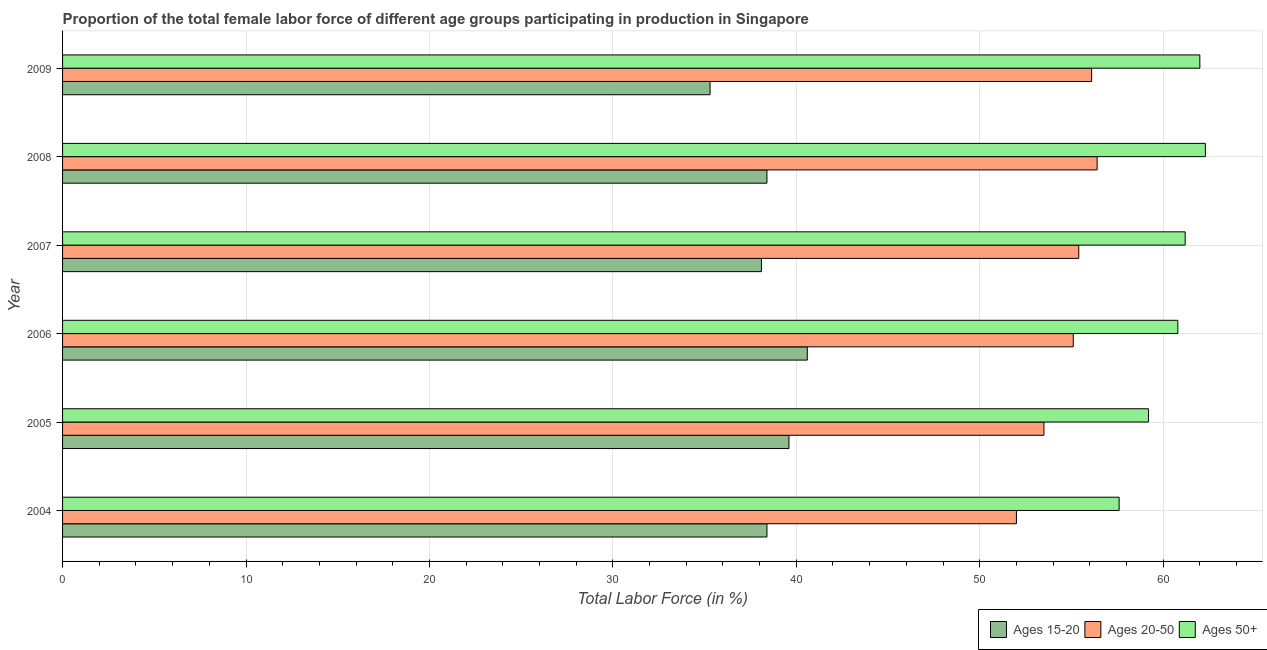How many groups of bars are there?
Offer a terse response. 6. Are the number of bars per tick equal to the number of legend labels?
Make the answer very short. Yes. Are the number of bars on each tick of the Y-axis equal?
Provide a short and direct response. Yes. How many bars are there on the 5th tick from the top?
Provide a succinct answer. 3. How many bars are there on the 2nd tick from the bottom?
Your answer should be very brief. 3. What is the label of the 3rd group of bars from the top?
Offer a very short reply. 2007. In how many cases, is the number of bars for a given year not equal to the number of legend labels?
Provide a succinct answer. 0. What is the percentage of female labor force within the age group 20-50 in 2004?
Your answer should be very brief. 52. Across all years, what is the maximum percentage of female labor force within the age group 20-50?
Ensure brevity in your answer.  56.4. Across all years, what is the minimum percentage of female labor force above age 50?
Provide a succinct answer. 57.6. In which year was the percentage of female labor force within the age group 20-50 maximum?
Your answer should be compact. 2008. What is the total percentage of female labor force within the age group 20-50 in the graph?
Make the answer very short. 328.5. What is the difference between the percentage of female labor force within the age group 20-50 in 2007 and the percentage of female labor force above age 50 in 2005?
Keep it short and to the point. -3.8. What is the average percentage of female labor force within the age group 15-20 per year?
Offer a terse response. 38.4. In the year 2004, what is the difference between the percentage of female labor force within the age group 15-20 and percentage of female labor force above age 50?
Your answer should be compact. -19.2. Is the percentage of female labor force within the age group 15-20 in 2004 less than that in 2005?
Your response must be concise. Yes. What is the difference between the highest and the lowest percentage of female labor force within the age group 20-50?
Give a very brief answer. 4.4. What does the 1st bar from the top in 2008 represents?
Your response must be concise. Ages 50+. What does the 3rd bar from the bottom in 2008 represents?
Offer a terse response. Ages 50+. Is it the case that in every year, the sum of the percentage of female labor force within the age group 15-20 and percentage of female labor force within the age group 20-50 is greater than the percentage of female labor force above age 50?
Your response must be concise. Yes. Are all the bars in the graph horizontal?
Keep it short and to the point. Yes. How many years are there in the graph?
Your answer should be compact. 6. What is the difference between two consecutive major ticks on the X-axis?
Your answer should be compact. 10. How many legend labels are there?
Your answer should be compact. 3. What is the title of the graph?
Make the answer very short. Proportion of the total female labor force of different age groups participating in production in Singapore. What is the label or title of the X-axis?
Ensure brevity in your answer.  Total Labor Force (in %). What is the label or title of the Y-axis?
Your response must be concise. Year. What is the Total Labor Force (in %) of Ages 15-20 in 2004?
Offer a very short reply. 38.4. What is the Total Labor Force (in %) of Ages 20-50 in 2004?
Your response must be concise. 52. What is the Total Labor Force (in %) of Ages 50+ in 2004?
Your response must be concise. 57.6. What is the Total Labor Force (in %) of Ages 15-20 in 2005?
Your answer should be very brief. 39.6. What is the Total Labor Force (in %) in Ages 20-50 in 2005?
Give a very brief answer. 53.5. What is the Total Labor Force (in %) of Ages 50+ in 2005?
Provide a short and direct response. 59.2. What is the Total Labor Force (in %) in Ages 15-20 in 2006?
Make the answer very short. 40.6. What is the Total Labor Force (in %) in Ages 20-50 in 2006?
Give a very brief answer. 55.1. What is the Total Labor Force (in %) of Ages 50+ in 2006?
Provide a succinct answer. 60.8. What is the Total Labor Force (in %) in Ages 15-20 in 2007?
Keep it short and to the point. 38.1. What is the Total Labor Force (in %) of Ages 20-50 in 2007?
Give a very brief answer. 55.4. What is the Total Labor Force (in %) in Ages 50+ in 2007?
Provide a succinct answer. 61.2. What is the Total Labor Force (in %) in Ages 15-20 in 2008?
Provide a succinct answer. 38.4. What is the Total Labor Force (in %) of Ages 20-50 in 2008?
Your response must be concise. 56.4. What is the Total Labor Force (in %) of Ages 50+ in 2008?
Make the answer very short. 62.3. What is the Total Labor Force (in %) of Ages 15-20 in 2009?
Give a very brief answer. 35.3. What is the Total Labor Force (in %) in Ages 20-50 in 2009?
Offer a very short reply. 56.1. What is the Total Labor Force (in %) of Ages 50+ in 2009?
Your answer should be very brief. 62. Across all years, what is the maximum Total Labor Force (in %) of Ages 15-20?
Your answer should be compact. 40.6. Across all years, what is the maximum Total Labor Force (in %) in Ages 20-50?
Your answer should be compact. 56.4. Across all years, what is the maximum Total Labor Force (in %) in Ages 50+?
Provide a succinct answer. 62.3. Across all years, what is the minimum Total Labor Force (in %) of Ages 15-20?
Keep it short and to the point. 35.3. Across all years, what is the minimum Total Labor Force (in %) in Ages 20-50?
Your answer should be very brief. 52. Across all years, what is the minimum Total Labor Force (in %) in Ages 50+?
Give a very brief answer. 57.6. What is the total Total Labor Force (in %) of Ages 15-20 in the graph?
Your answer should be compact. 230.4. What is the total Total Labor Force (in %) of Ages 20-50 in the graph?
Your answer should be very brief. 328.5. What is the total Total Labor Force (in %) of Ages 50+ in the graph?
Your response must be concise. 363.1. What is the difference between the Total Labor Force (in %) of Ages 15-20 in 2004 and that in 2005?
Give a very brief answer. -1.2. What is the difference between the Total Labor Force (in %) in Ages 15-20 in 2004 and that in 2006?
Keep it short and to the point. -2.2. What is the difference between the Total Labor Force (in %) of Ages 50+ in 2004 and that in 2006?
Offer a terse response. -3.2. What is the difference between the Total Labor Force (in %) of Ages 15-20 in 2004 and that in 2007?
Give a very brief answer. 0.3. What is the difference between the Total Labor Force (in %) of Ages 50+ in 2004 and that in 2007?
Provide a succinct answer. -3.6. What is the difference between the Total Labor Force (in %) in Ages 50+ in 2004 and that in 2008?
Your answer should be compact. -4.7. What is the difference between the Total Labor Force (in %) of Ages 20-50 in 2004 and that in 2009?
Make the answer very short. -4.1. What is the difference between the Total Labor Force (in %) in Ages 20-50 in 2005 and that in 2006?
Offer a terse response. -1.6. What is the difference between the Total Labor Force (in %) of Ages 50+ in 2005 and that in 2006?
Offer a terse response. -1.6. What is the difference between the Total Labor Force (in %) of Ages 15-20 in 2005 and that in 2007?
Offer a terse response. 1.5. What is the difference between the Total Labor Force (in %) in Ages 20-50 in 2005 and that in 2007?
Your answer should be very brief. -1.9. What is the difference between the Total Labor Force (in %) of Ages 20-50 in 2005 and that in 2008?
Ensure brevity in your answer.  -2.9. What is the difference between the Total Labor Force (in %) in Ages 15-20 in 2005 and that in 2009?
Make the answer very short. 4.3. What is the difference between the Total Labor Force (in %) of Ages 20-50 in 2006 and that in 2007?
Give a very brief answer. -0.3. What is the difference between the Total Labor Force (in %) of Ages 50+ in 2006 and that in 2007?
Give a very brief answer. -0.4. What is the difference between the Total Labor Force (in %) in Ages 15-20 in 2006 and that in 2008?
Provide a short and direct response. 2.2. What is the difference between the Total Labor Force (in %) in Ages 20-50 in 2006 and that in 2008?
Give a very brief answer. -1.3. What is the difference between the Total Labor Force (in %) in Ages 20-50 in 2006 and that in 2009?
Offer a very short reply. -1. What is the difference between the Total Labor Force (in %) of Ages 50+ in 2006 and that in 2009?
Provide a short and direct response. -1.2. What is the difference between the Total Labor Force (in %) in Ages 15-20 in 2007 and that in 2008?
Keep it short and to the point. -0.3. What is the difference between the Total Labor Force (in %) in Ages 50+ in 2007 and that in 2008?
Keep it short and to the point. -1.1. What is the difference between the Total Labor Force (in %) in Ages 15-20 in 2007 and that in 2009?
Offer a terse response. 2.8. What is the difference between the Total Labor Force (in %) in Ages 20-50 in 2007 and that in 2009?
Your response must be concise. -0.7. What is the difference between the Total Labor Force (in %) of Ages 50+ in 2007 and that in 2009?
Ensure brevity in your answer.  -0.8. What is the difference between the Total Labor Force (in %) of Ages 15-20 in 2008 and that in 2009?
Provide a short and direct response. 3.1. What is the difference between the Total Labor Force (in %) of Ages 20-50 in 2008 and that in 2009?
Offer a very short reply. 0.3. What is the difference between the Total Labor Force (in %) of Ages 15-20 in 2004 and the Total Labor Force (in %) of Ages 20-50 in 2005?
Your answer should be compact. -15.1. What is the difference between the Total Labor Force (in %) in Ages 15-20 in 2004 and the Total Labor Force (in %) in Ages 50+ in 2005?
Give a very brief answer. -20.8. What is the difference between the Total Labor Force (in %) of Ages 20-50 in 2004 and the Total Labor Force (in %) of Ages 50+ in 2005?
Your response must be concise. -7.2. What is the difference between the Total Labor Force (in %) of Ages 15-20 in 2004 and the Total Labor Force (in %) of Ages 20-50 in 2006?
Your answer should be very brief. -16.7. What is the difference between the Total Labor Force (in %) of Ages 15-20 in 2004 and the Total Labor Force (in %) of Ages 50+ in 2006?
Provide a succinct answer. -22.4. What is the difference between the Total Labor Force (in %) of Ages 20-50 in 2004 and the Total Labor Force (in %) of Ages 50+ in 2006?
Ensure brevity in your answer.  -8.8. What is the difference between the Total Labor Force (in %) of Ages 15-20 in 2004 and the Total Labor Force (in %) of Ages 50+ in 2007?
Ensure brevity in your answer.  -22.8. What is the difference between the Total Labor Force (in %) of Ages 20-50 in 2004 and the Total Labor Force (in %) of Ages 50+ in 2007?
Ensure brevity in your answer.  -9.2. What is the difference between the Total Labor Force (in %) in Ages 15-20 in 2004 and the Total Labor Force (in %) in Ages 20-50 in 2008?
Give a very brief answer. -18. What is the difference between the Total Labor Force (in %) of Ages 15-20 in 2004 and the Total Labor Force (in %) of Ages 50+ in 2008?
Your answer should be compact. -23.9. What is the difference between the Total Labor Force (in %) in Ages 15-20 in 2004 and the Total Labor Force (in %) in Ages 20-50 in 2009?
Your answer should be very brief. -17.7. What is the difference between the Total Labor Force (in %) in Ages 15-20 in 2004 and the Total Labor Force (in %) in Ages 50+ in 2009?
Offer a very short reply. -23.6. What is the difference between the Total Labor Force (in %) of Ages 20-50 in 2004 and the Total Labor Force (in %) of Ages 50+ in 2009?
Your response must be concise. -10. What is the difference between the Total Labor Force (in %) in Ages 15-20 in 2005 and the Total Labor Force (in %) in Ages 20-50 in 2006?
Provide a short and direct response. -15.5. What is the difference between the Total Labor Force (in %) in Ages 15-20 in 2005 and the Total Labor Force (in %) in Ages 50+ in 2006?
Give a very brief answer. -21.2. What is the difference between the Total Labor Force (in %) of Ages 20-50 in 2005 and the Total Labor Force (in %) of Ages 50+ in 2006?
Ensure brevity in your answer.  -7.3. What is the difference between the Total Labor Force (in %) of Ages 15-20 in 2005 and the Total Labor Force (in %) of Ages 20-50 in 2007?
Ensure brevity in your answer.  -15.8. What is the difference between the Total Labor Force (in %) of Ages 15-20 in 2005 and the Total Labor Force (in %) of Ages 50+ in 2007?
Ensure brevity in your answer.  -21.6. What is the difference between the Total Labor Force (in %) in Ages 15-20 in 2005 and the Total Labor Force (in %) in Ages 20-50 in 2008?
Give a very brief answer. -16.8. What is the difference between the Total Labor Force (in %) in Ages 15-20 in 2005 and the Total Labor Force (in %) in Ages 50+ in 2008?
Your answer should be compact. -22.7. What is the difference between the Total Labor Force (in %) of Ages 15-20 in 2005 and the Total Labor Force (in %) of Ages 20-50 in 2009?
Ensure brevity in your answer.  -16.5. What is the difference between the Total Labor Force (in %) of Ages 15-20 in 2005 and the Total Labor Force (in %) of Ages 50+ in 2009?
Provide a short and direct response. -22.4. What is the difference between the Total Labor Force (in %) of Ages 15-20 in 2006 and the Total Labor Force (in %) of Ages 20-50 in 2007?
Give a very brief answer. -14.8. What is the difference between the Total Labor Force (in %) of Ages 15-20 in 2006 and the Total Labor Force (in %) of Ages 50+ in 2007?
Keep it short and to the point. -20.6. What is the difference between the Total Labor Force (in %) of Ages 20-50 in 2006 and the Total Labor Force (in %) of Ages 50+ in 2007?
Offer a terse response. -6.1. What is the difference between the Total Labor Force (in %) in Ages 15-20 in 2006 and the Total Labor Force (in %) in Ages 20-50 in 2008?
Offer a very short reply. -15.8. What is the difference between the Total Labor Force (in %) of Ages 15-20 in 2006 and the Total Labor Force (in %) of Ages 50+ in 2008?
Offer a very short reply. -21.7. What is the difference between the Total Labor Force (in %) in Ages 20-50 in 2006 and the Total Labor Force (in %) in Ages 50+ in 2008?
Ensure brevity in your answer.  -7.2. What is the difference between the Total Labor Force (in %) of Ages 15-20 in 2006 and the Total Labor Force (in %) of Ages 20-50 in 2009?
Offer a very short reply. -15.5. What is the difference between the Total Labor Force (in %) of Ages 15-20 in 2006 and the Total Labor Force (in %) of Ages 50+ in 2009?
Provide a short and direct response. -21.4. What is the difference between the Total Labor Force (in %) in Ages 20-50 in 2006 and the Total Labor Force (in %) in Ages 50+ in 2009?
Your answer should be compact. -6.9. What is the difference between the Total Labor Force (in %) in Ages 15-20 in 2007 and the Total Labor Force (in %) in Ages 20-50 in 2008?
Make the answer very short. -18.3. What is the difference between the Total Labor Force (in %) of Ages 15-20 in 2007 and the Total Labor Force (in %) of Ages 50+ in 2008?
Provide a succinct answer. -24.2. What is the difference between the Total Labor Force (in %) of Ages 15-20 in 2007 and the Total Labor Force (in %) of Ages 50+ in 2009?
Give a very brief answer. -23.9. What is the difference between the Total Labor Force (in %) of Ages 20-50 in 2007 and the Total Labor Force (in %) of Ages 50+ in 2009?
Make the answer very short. -6.6. What is the difference between the Total Labor Force (in %) in Ages 15-20 in 2008 and the Total Labor Force (in %) in Ages 20-50 in 2009?
Give a very brief answer. -17.7. What is the difference between the Total Labor Force (in %) of Ages 15-20 in 2008 and the Total Labor Force (in %) of Ages 50+ in 2009?
Provide a short and direct response. -23.6. What is the average Total Labor Force (in %) of Ages 15-20 per year?
Your answer should be compact. 38.4. What is the average Total Labor Force (in %) in Ages 20-50 per year?
Your answer should be very brief. 54.75. What is the average Total Labor Force (in %) of Ages 50+ per year?
Offer a very short reply. 60.52. In the year 2004, what is the difference between the Total Labor Force (in %) of Ages 15-20 and Total Labor Force (in %) of Ages 50+?
Your answer should be very brief. -19.2. In the year 2004, what is the difference between the Total Labor Force (in %) in Ages 20-50 and Total Labor Force (in %) in Ages 50+?
Ensure brevity in your answer.  -5.6. In the year 2005, what is the difference between the Total Labor Force (in %) of Ages 15-20 and Total Labor Force (in %) of Ages 20-50?
Offer a very short reply. -13.9. In the year 2005, what is the difference between the Total Labor Force (in %) in Ages 15-20 and Total Labor Force (in %) in Ages 50+?
Give a very brief answer. -19.6. In the year 2005, what is the difference between the Total Labor Force (in %) in Ages 20-50 and Total Labor Force (in %) in Ages 50+?
Provide a succinct answer. -5.7. In the year 2006, what is the difference between the Total Labor Force (in %) of Ages 15-20 and Total Labor Force (in %) of Ages 20-50?
Keep it short and to the point. -14.5. In the year 2006, what is the difference between the Total Labor Force (in %) in Ages 15-20 and Total Labor Force (in %) in Ages 50+?
Offer a terse response. -20.2. In the year 2006, what is the difference between the Total Labor Force (in %) of Ages 20-50 and Total Labor Force (in %) of Ages 50+?
Ensure brevity in your answer.  -5.7. In the year 2007, what is the difference between the Total Labor Force (in %) in Ages 15-20 and Total Labor Force (in %) in Ages 20-50?
Ensure brevity in your answer.  -17.3. In the year 2007, what is the difference between the Total Labor Force (in %) in Ages 15-20 and Total Labor Force (in %) in Ages 50+?
Your answer should be compact. -23.1. In the year 2008, what is the difference between the Total Labor Force (in %) in Ages 15-20 and Total Labor Force (in %) in Ages 50+?
Keep it short and to the point. -23.9. In the year 2009, what is the difference between the Total Labor Force (in %) in Ages 15-20 and Total Labor Force (in %) in Ages 20-50?
Give a very brief answer. -20.8. In the year 2009, what is the difference between the Total Labor Force (in %) in Ages 15-20 and Total Labor Force (in %) in Ages 50+?
Provide a short and direct response. -26.7. In the year 2009, what is the difference between the Total Labor Force (in %) in Ages 20-50 and Total Labor Force (in %) in Ages 50+?
Offer a very short reply. -5.9. What is the ratio of the Total Labor Force (in %) of Ages 15-20 in 2004 to that in 2005?
Your answer should be very brief. 0.97. What is the ratio of the Total Labor Force (in %) in Ages 50+ in 2004 to that in 2005?
Provide a short and direct response. 0.97. What is the ratio of the Total Labor Force (in %) in Ages 15-20 in 2004 to that in 2006?
Offer a very short reply. 0.95. What is the ratio of the Total Labor Force (in %) in Ages 20-50 in 2004 to that in 2006?
Your answer should be very brief. 0.94. What is the ratio of the Total Labor Force (in %) in Ages 50+ in 2004 to that in 2006?
Offer a terse response. 0.95. What is the ratio of the Total Labor Force (in %) of Ages 15-20 in 2004 to that in 2007?
Your answer should be very brief. 1.01. What is the ratio of the Total Labor Force (in %) in Ages 20-50 in 2004 to that in 2007?
Provide a succinct answer. 0.94. What is the ratio of the Total Labor Force (in %) of Ages 15-20 in 2004 to that in 2008?
Offer a very short reply. 1. What is the ratio of the Total Labor Force (in %) in Ages 20-50 in 2004 to that in 2008?
Offer a very short reply. 0.92. What is the ratio of the Total Labor Force (in %) of Ages 50+ in 2004 to that in 2008?
Provide a succinct answer. 0.92. What is the ratio of the Total Labor Force (in %) in Ages 15-20 in 2004 to that in 2009?
Give a very brief answer. 1.09. What is the ratio of the Total Labor Force (in %) of Ages 20-50 in 2004 to that in 2009?
Keep it short and to the point. 0.93. What is the ratio of the Total Labor Force (in %) of Ages 50+ in 2004 to that in 2009?
Provide a short and direct response. 0.93. What is the ratio of the Total Labor Force (in %) of Ages 15-20 in 2005 to that in 2006?
Provide a succinct answer. 0.98. What is the ratio of the Total Labor Force (in %) of Ages 50+ in 2005 to that in 2006?
Offer a terse response. 0.97. What is the ratio of the Total Labor Force (in %) in Ages 15-20 in 2005 to that in 2007?
Your answer should be very brief. 1.04. What is the ratio of the Total Labor Force (in %) of Ages 20-50 in 2005 to that in 2007?
Make the answer very short. 0.97. What is the ratio of the Total Labor Force (in %) in Ages 50+ in 2005 to that in 2007?
Your response must be concise. 0.97. What is the ratio of the Total Labor Force (in %) of Ages 15-20 in 2005 to that in 2008?
Offer a terse response. 1.03. What is the ratio of the Total Labor Force (in %) in Ages 20-50 in 2005 to that in 2008?
Offer a very short reply. 0.95. What is the ratio of the Total Labor Force (in %) of Ages 50+ in 2005 to that in 2008?
Give a very brief answer. 0.95. What is the ratio of the Total Labor Force (in %) of Ages 15-20 in 2005 to that in 2009?
Provide a short and direct response. 1.12. What is the ratio of the Total Labor Force (in %) of Ages 20-50 in 2005 to that in 2009?
Offer a very short reply. 0.95. What is the ratio of the Total Labor Force (in %) in Ages 50+ in 2005 to that in 2009?
Ensure brevity in your answer.  0.95. What is the ratio of the Total Labor Force (in %) of Ages 15-20 in 2006 to that in 2007?
Ensure brevity in your answer.  1.07. What is the ratio of the Total Labor Force (in %) in Ages 50+ in 2006 to that in 2007?
Give a very brief answer. 0.99. What is the ratio of the Total Labor Force (in %) of Ages 15-20 in 2006 to that in 2008?
Offer a very short reply. 1.06. What is the ratio of the Total Labor Force (in %) in Ages 20-50 in 2006 to that in 2008?
Your answer should be compact. 0.98. What is the ratio of the Total Labor Force (in %) of Ages 50+ in 2006 to that in 2008?
Provide a succinct answer. 0.98. What is the ratio of the Total Labor Force (in %) in Ages 15-20 in 2006 to that in 2009?
Your answer should be very brief. 1.15. What is the ratio of the Total Labor Force (in %) of Ages 20-50 in 2006 to that in 2009?
Ensure brevity in your answer.  0.98. What is the ratio of the Total Labor Force (in %) in Ages 50+ in 2006 to that in 2009?
Offer a terse response. 0.98. What is the ratio of the Total Labor Force (in %) of Ages 20-50 in 2007 to that in 2008?
Your answer should be very brief. 0.98. What is the ratio of the Total Labor Force (in %) of Ages 50+ in 2007 to that in 2008?
Give a very brief answer. 0.98. What is the ratio of the Total Labor Force (in %) in Ages 15-20 in 2007 to that in 2009?
Keep it short and to the point. 1.08. What is the ratio of the Total Labor Force (in %) in Ages 20-50 in 2007 to that in 2009?
Provide a succinct answer. 0.99. What is the ratio of the Total Labor Force (in %) of Ages 50+ in 2007 to that in 2009?
Make the answer very short. 0.99. What is the ratio of the Total Labor Force (in %) of Ages 15-20 in 2008 to that in 2009?
Your response must be concise. 1.09. What is the ratio of the Total Labor Force (in %) in Ages 20-50 in 2008 to that in 2009?
Ensure brevity in your answer.  1.01. What is the ratio of the Total Labor Force (in %) of Ages 50+ in 2008 to that in 2009?
Offer a terse response. 1. 